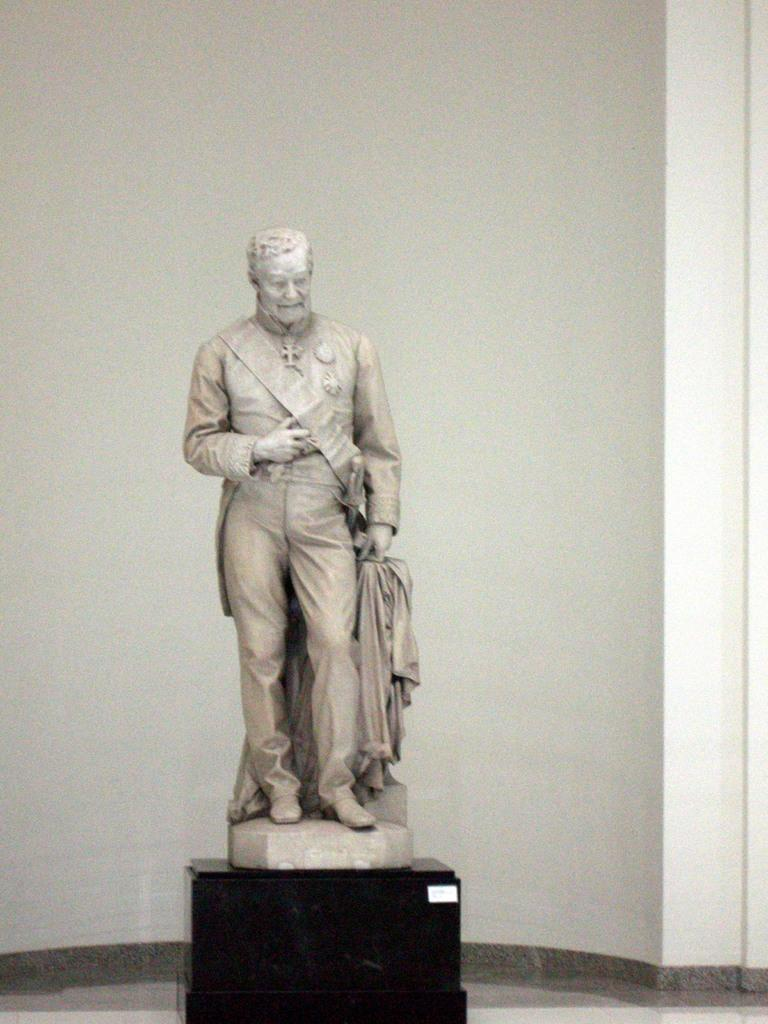What is the main subject in the image? There is a statue in the image. What can be seen in the background of the image? There is a white color wall in the image. What type of jam is being spread on the statue in the image? There is no jam present in the image, and the statue is not being used for spreading jam. 